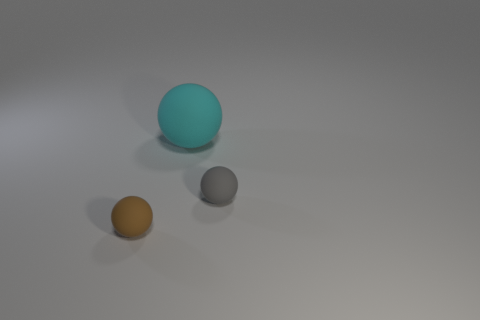Do the brown matte thing and the cyan rubber thing have the same size?
Give a very brief answer. No. What is the material of the sphere that is in front of the gray matte sphere?
Offer a very short reply. Rubber. What material is the big thing that is the same shape as the tiny brown object?
Provide a succinct answer. Rubber. Is there a gray matte object to the left of the tiny brown matte thing in front of the large cyan object?
Your response must be concise. No. Is the shape of the big cyan rubber object the same as the gray thing?
Give a very brief answer. Yes. There is another brown object that is made of the same material as the large object; what is its shape?
Offer a very short reply. Sphere. There is a cyan rubber ball to the right of the small brown rubber thing; does it have the same size as the matte thing to the left of the big matte sphere?
Keep it short and to the point. No. Is the number of small matte things that are on the left side of the tiny gray matte sphere greater than the number of small objects right of the brown ball?
Your answer should be very brief. No. How many other things are there of the same color as the large thing?
Make the answer very short. 0. There is a big ball; is its color the same as the tiny rubber thing right of the tiny brown object?
Your response must be concise. No. 